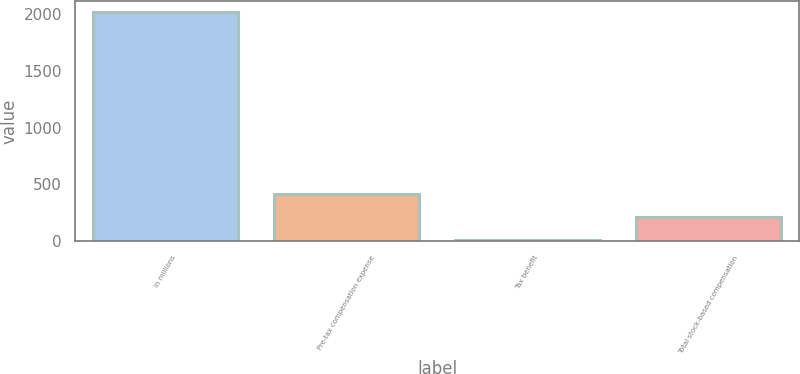Convert chart. <chart><loc_0><loc_0><loc_500><loc_500><bar_chart><fcel>In millions<fcel>Pre-tax compensation expense<fcel>Tax benefit<fcel>Total stock-based compensation<nl><fcel>2016<fcel>413.6<fcel>13<fcel>213.3<nl></chart> 